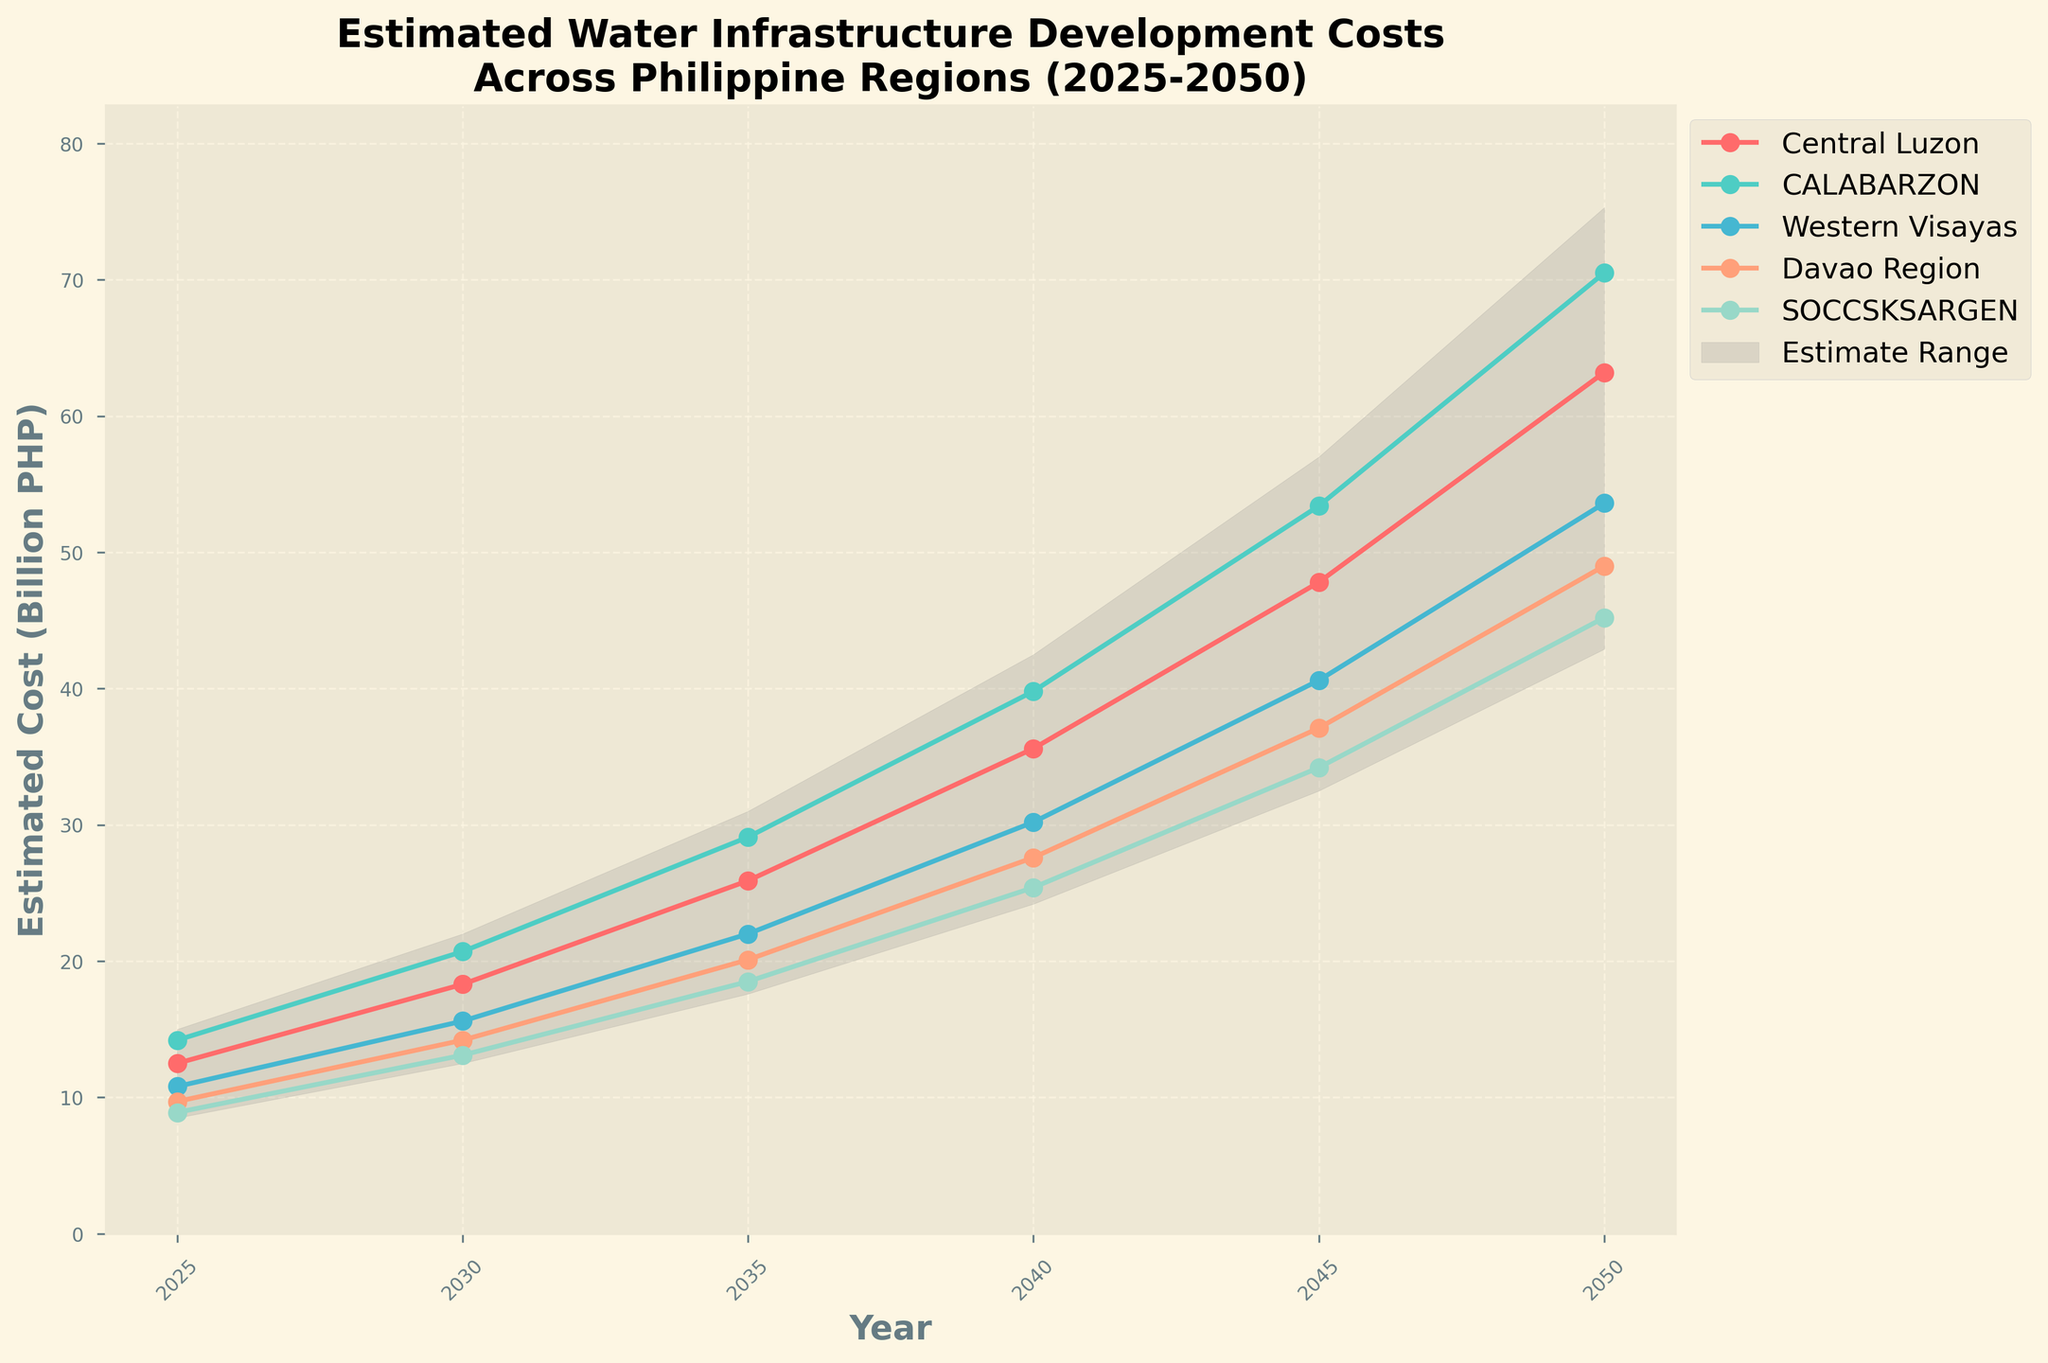What is the title of the figure? The title is displayed at the top of the figure. It summarizes the topic of the data presented.
Answer: "Estimated Water Infrastructure Development Costs Across Philippine Regions (2025-2050)" How many regions are displayed in this figure? The figure contains separate lines for each region displayed in the legend and plotted on the chart. The legend lists five regions.
Answer: 5 Which region has the highest estimated cost in 2050? To determine this, you should look at the end points of each plotted line for the year 2050. The highest point indicates the region with the highest estimated cost.
Answer: CALABARZON What is the estimated cost range for 2040? The range is depicted by the shaded gray area between the low and high estimate lines. The estimates for 2040 are 24.2 and 42.5.
Answer: 18.3 Billion PHP What year does the estimated cost for SOCCSKSARGEN first exceed 25 Billion PHP? Observe the plotted line for SOCCSKSARGEN and see where it first crosses the 25 Billion PHP mark on the y-axis. This occurs between 2035 and 2040.
Answer: 2040 Compare the estimated costs for Central Luzon and Western Visayas in 2030. Which is higher and by how much? Check the y-values for both regions in 2030 in the figure. Central Luzon has an estimated cost of 18.3 Billion PHP, while Western Visayas has 15.6 Billion PHP. The difference is 18.3 - 15.6.
Answer: Central Luzon by 2.7 Billion PHP What is the average estimated cost for Davao Region from 2025 to 2050? Sum up all the values for Davao Region given for all the years and then divide by the number of years (2025, 2030, 2035, 2040, 2045, 2050). The sum is 9.7 + 14.2 + 20.1 + 27.6 + 37.1 + 49.0 = 157.7, and there are 6 years.
Answer: 26.28 Billion PHP Which year sees the highest estimate for the high estimate range? Look at the high estimate line plotted on the chart and see which year’s value is the highest. The highest estimate line value is in 2050.
Answer: 2050 In 2035, how many regions have an estimated development cost below the low estimate? Compare the estimated costs of all the regions in 2035 (Central Luzon, CALABARZON, Western Visayas, Davao Region, and SOCCSKSARGEN) with the low estimate value of 17.6 for that year. None of the regional estimates fall below the low estimate.
Answer: 0 